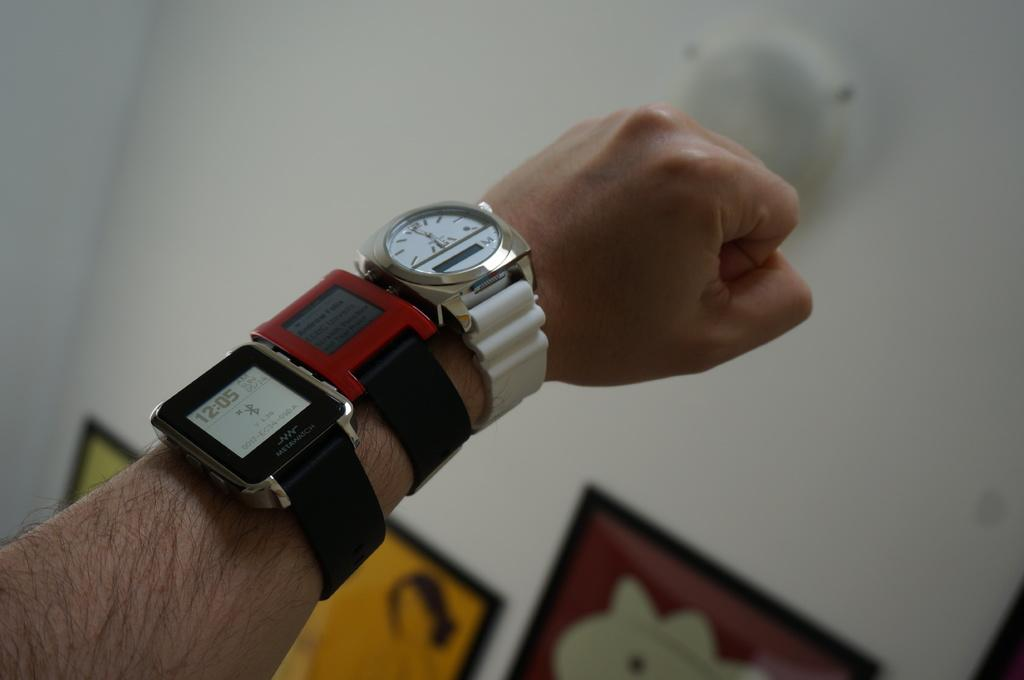<image>
Create a compact narrative representing the image presented. Person wearing three watches including one that says 12:05. 